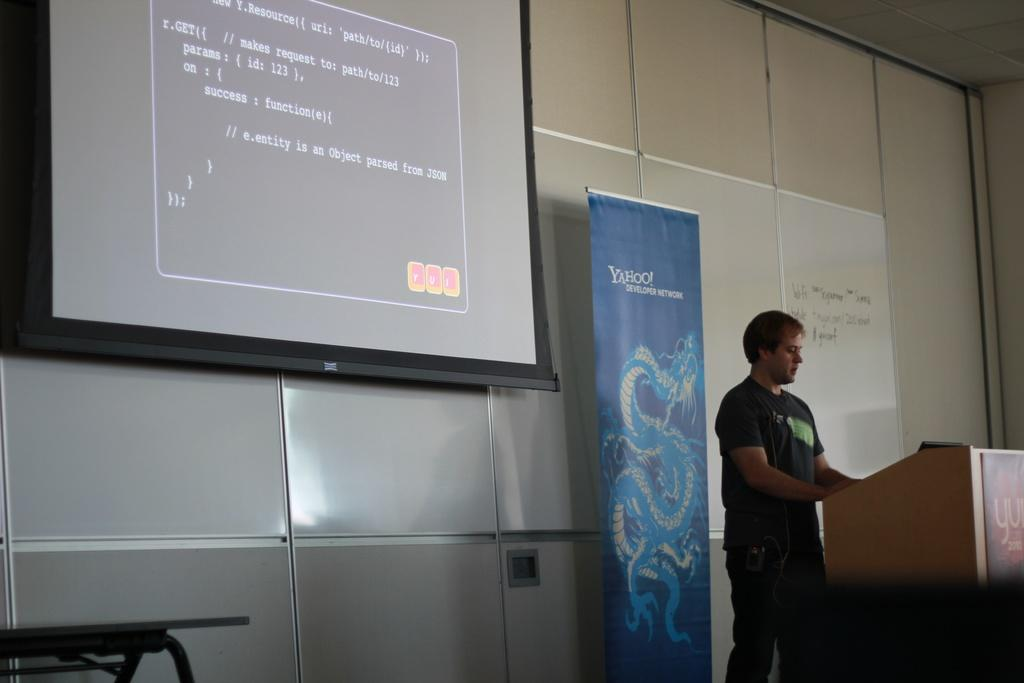<image>
Relay a brief, clear account of the picture shown. a man at a podium with a yahoo banner directly behind him. 